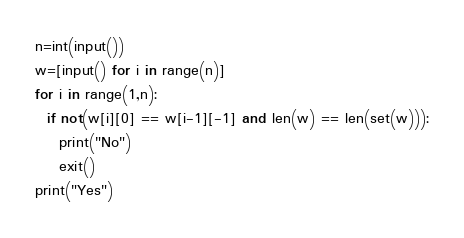<code> <loc_0><loc_0><loc_500><loc_500><_Python_>n=int(input())
w=[input() for i in range(n)]
for i in range(1,n):
  if not(w[i][0] == w[i-1][-1] and len(w) == len(set(w))):
    print("No")
    exit()
print("Yes")</code> 